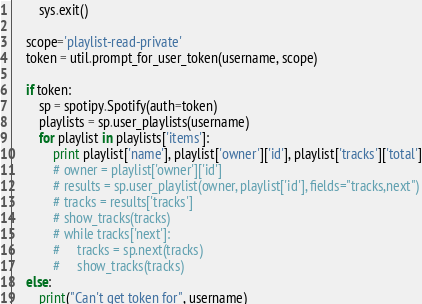Convert code to text. <code><loc_0><loc_0><loc_500><loc_500><_Python_>        sys.exit()

    scope='playlist-read-private'
    token = util.prompt_for_user_token(username, scope)

    if token:
        sp = spotipy.Spotify(auth=token)
        playlists = sp.user_playlists(username)
        for playlist in playlists['items']:
            print playlist['name'], playlist['owner']['id'], playlist['tracks']['total']
            # owner = playlist['owner']['id']
            # results = sp.user_playlist(owner, playlist['id'], fields="tracks,next")
            # tracks = results['tracks']
            # show_tracks(tracks)
            # while tracks['next']:
            #     tracks = sp.next(tracks)
            #     show_tracks(tracks)
    else:
        print("Can't get token for", username)

</code> 